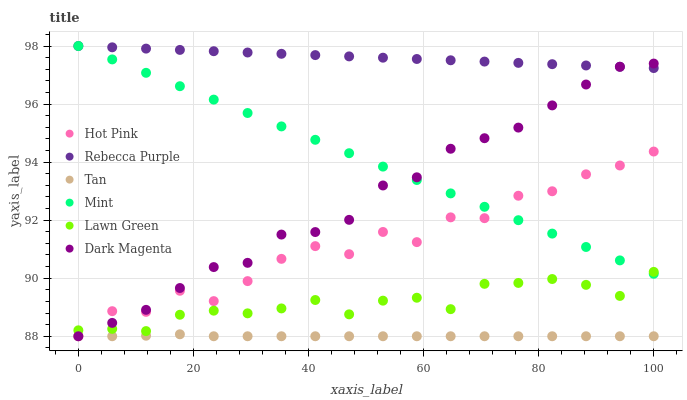Does Tan have the minimum area under the curve?
Answer yes or no. Yes. Does Rebecca Purple have the maximum area under the curve?
Answer yes or no. Yes. Does Dark Magenta have the minimum area under the curve?
Answer yes or no. No. Does Dark Magenta have the maximum area under the curve?
Answer yes or no. No. Is Mint the smoothest?
Answer yes or no. Yes. Is Hot Pink the roughest?
Answer yes or no. Yes. Is Dark Magenta the smoothest?
Answer yes or no. No. Is Dark Magenta the roughest?
Answer yes or no. No. Does Dark Magenta have the lowest value?
Answer yes or no. Yes. Does Rebecca Purple have the lowest value?
Answer yes or no. No. Does Mint have the highest value?
Answer yes or no. Yes. Does Dark Magenta have the highest value?
Answer yes or no. No. Is Tan less than Lawn Green?
Answer yes or no. Yes. Is Lawn Green greater than Tan?
Answer yes or no. Yes. Does Mint intersect Dark Magenta?
Answer yes or no. Yes. Is Mint less than Dark Magenta?
Answer yes or no. No. Is Mint greater than Dark Magenta?
Answer yes or no. No. Does Tan intersect Lawn Green?
Answer yes or no. No. 